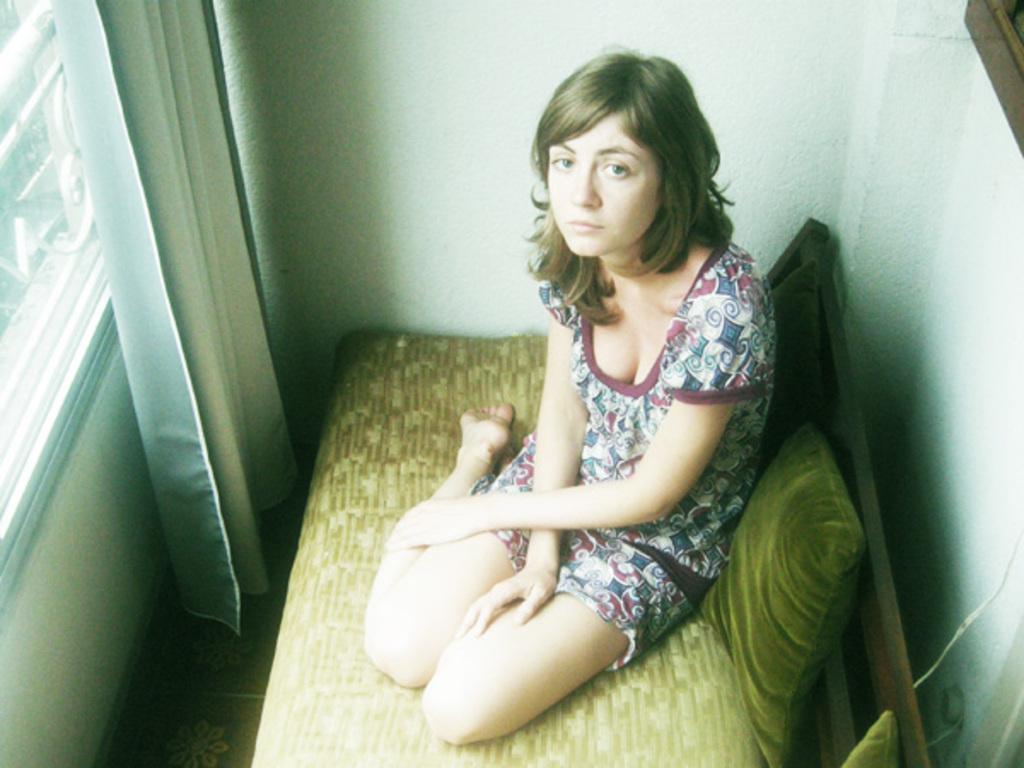How would you summarize this image in a sentence or two? In this image we can see a lady sitting on the sofa. There are cushions placed on the sofa. On the left there is a window and we can see a curtain. In the background there is a wall. 